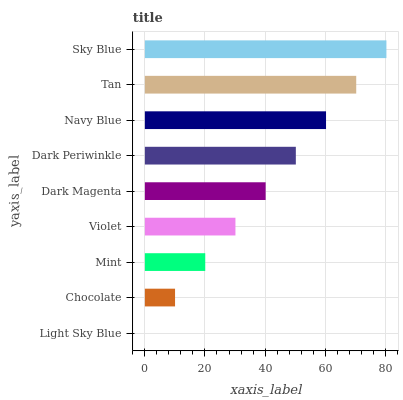Is Light Sky Blue the minimum?
Answer yes or no. Yes. Is Sky Blue the maximum?
Answer yes or no. Yes. Is Chocolate the minimum?
Answer yes or no. No. Is Chocolate the maximum?
Answer yes or no. No. Is Chocolate greater than Light Sky Blue?
Answer yes or no. Yes. Is Light Sky Blue less than Chocolate?
Answer yes or no. Yes. Is Light Sky Blue greater than Chocolate?
Answer yes or no. No. Is Chocolate less than Light Sky Blue?
Answer yes or no. No. Is Dark Magenta the high median?
Answer yes or no. Yes. Is Dark Magenta the low median?
Answer yes or no. Yes. Is Mint the high median?
Answer yes or no. No. Is Sky Blue the low median?
Answer yes or no. No. 